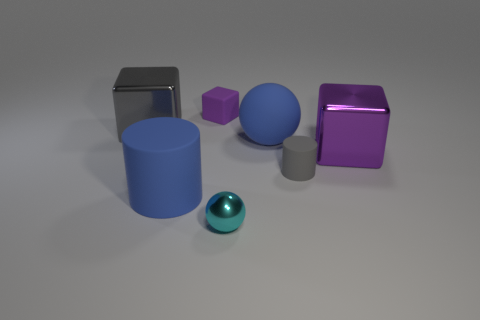Subtract all blue cubes. Subtract all green balls. How many cubes are left? 3 Add 3 small red cubes. How many objects exist? 10 Subtract all cylinders. How many objects are left? 5 Subtract all gray rubber cylinders. Subtract all small rubber things. How many objects are left? 4 Add 4 gray shiny things. How many gray shiny things are left? 5 Add 3 brown metal blocks. How many brown metal blocks exist? 3 Subtract 0 cyan cubes. How many objects are left? 7 